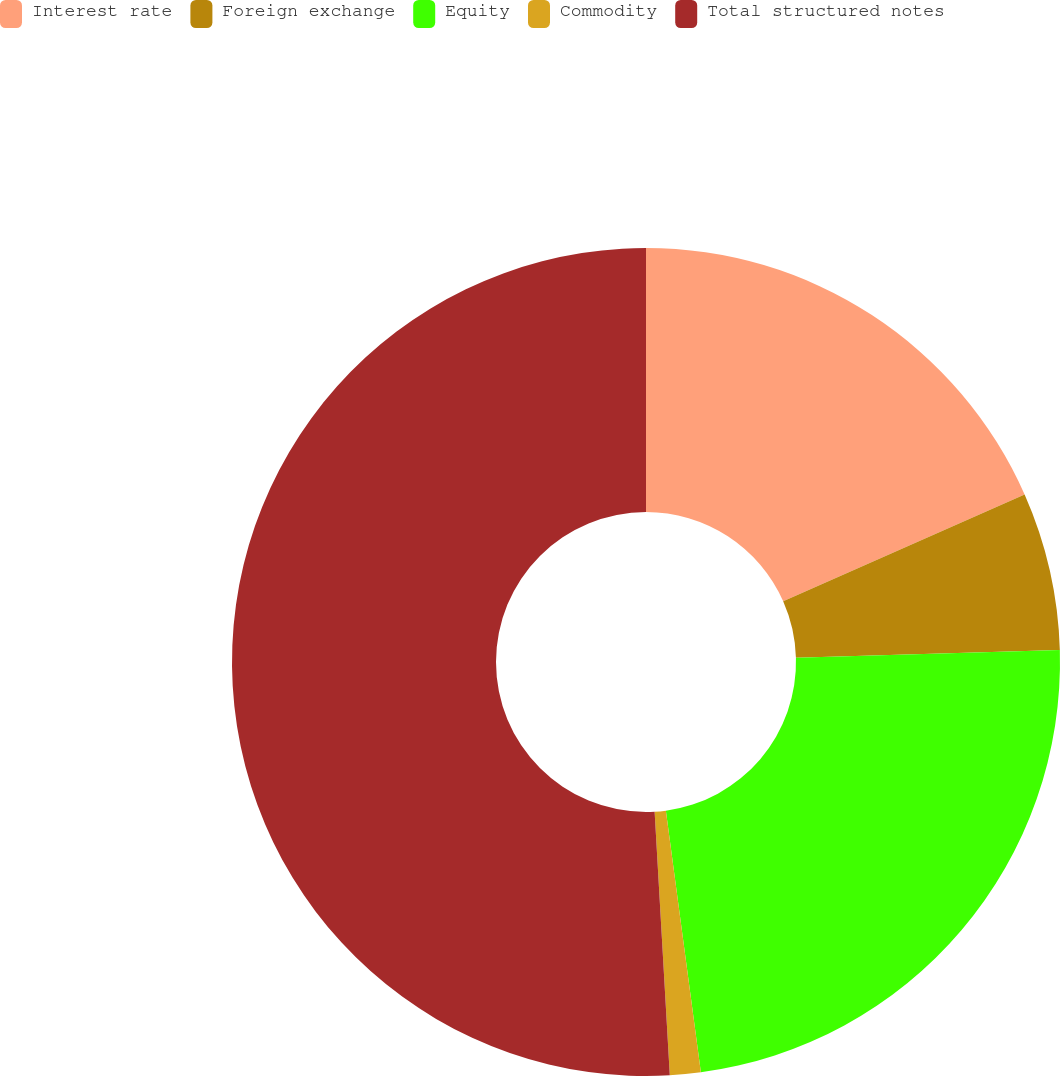Convert chart. <chart><loc_0><loc_0><loc_500><loc_500><pie_chart><fcel>Interest rate<fcel>Foreign exchange<fcel>Equity<fcel>Commodity<fcel>Total structured notes<nl><fcel>18.37%<fcel>6.17%<fcel>23.34%<fcel>1.2%<fcel>50.91%<nl></chart> 